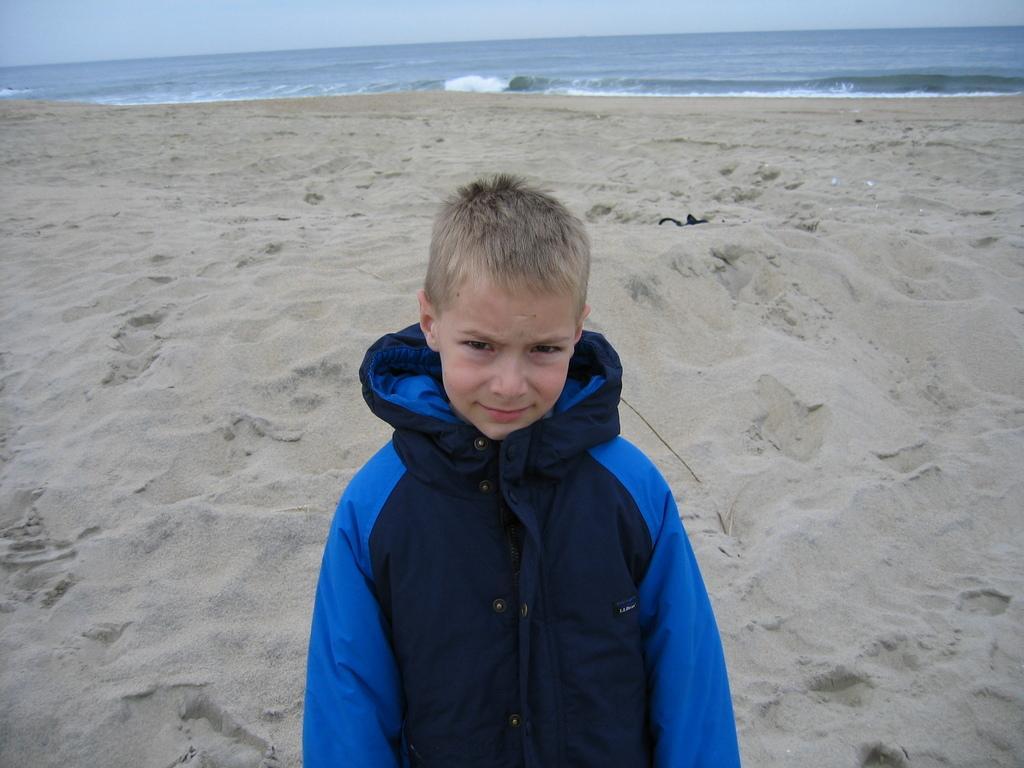In one or two sentences, can you explain what this image depicts? This picture is clicked outside. In the foreground there is a kid standing. In the background we can see the sky, water body and the mud. 